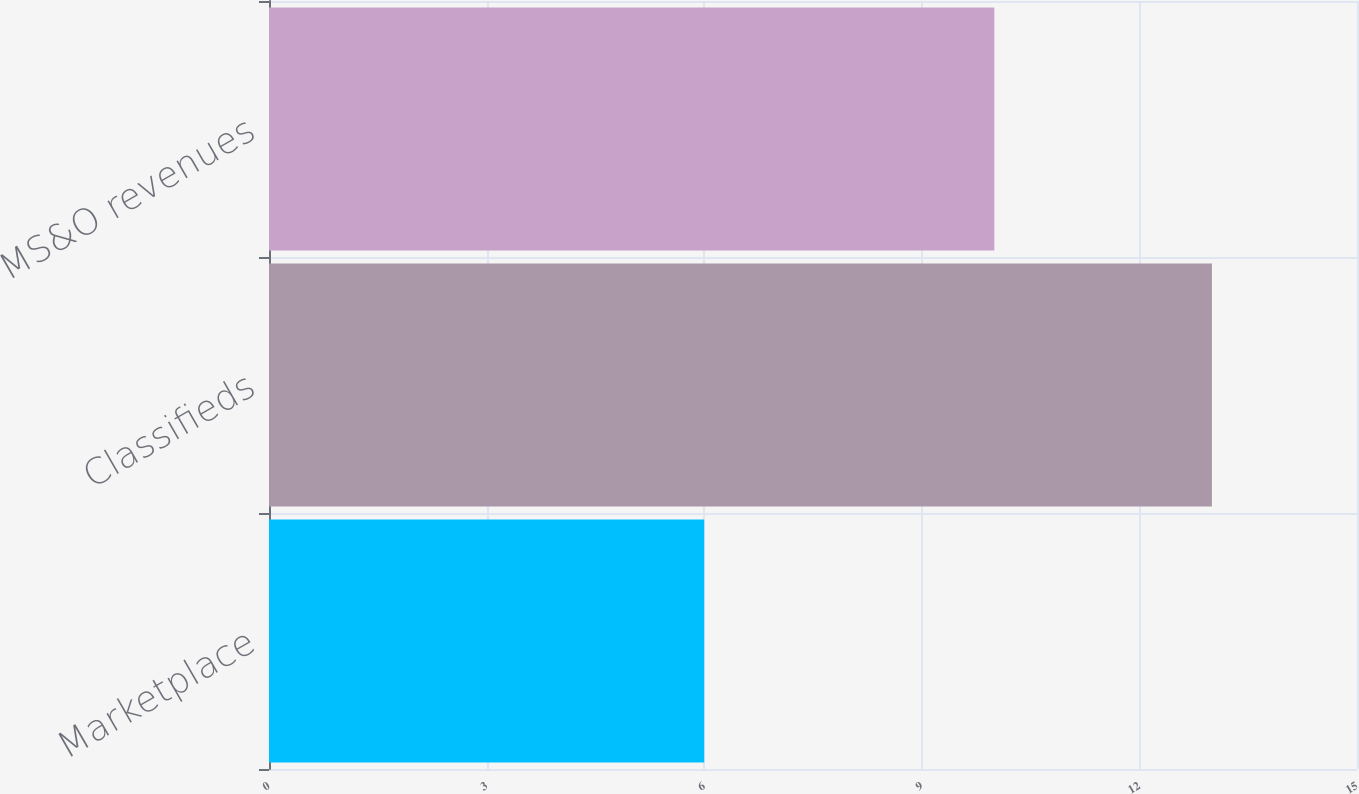<chart> <loc_0><loc_0><loc_500><loc_500><bar_chart><fcel>Marketplace<fcel>Classifieds<fcel>Total MS&O revenues<nl><fcel>6<fcel>13<fcel>10<nl></chart> 